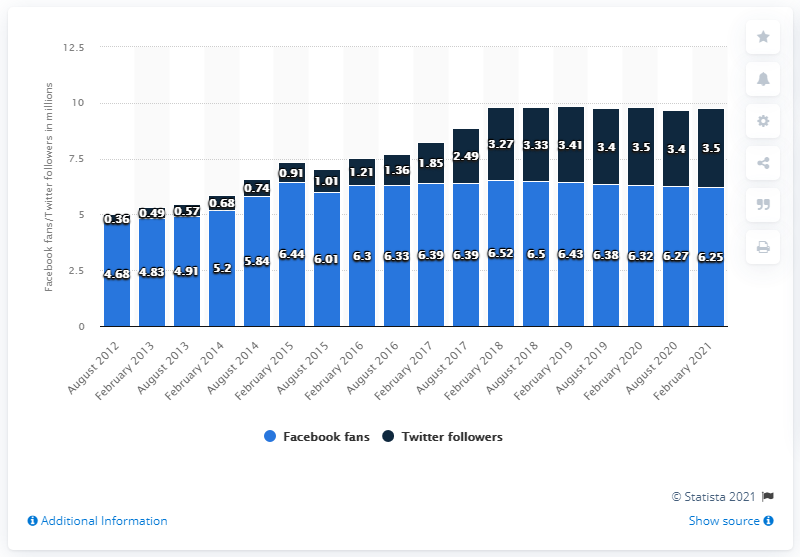List a handful of essential elements in this visual. In February 2021, the Pittsburgh Steelers football team had approximately 6.25 million Facebook followers. 